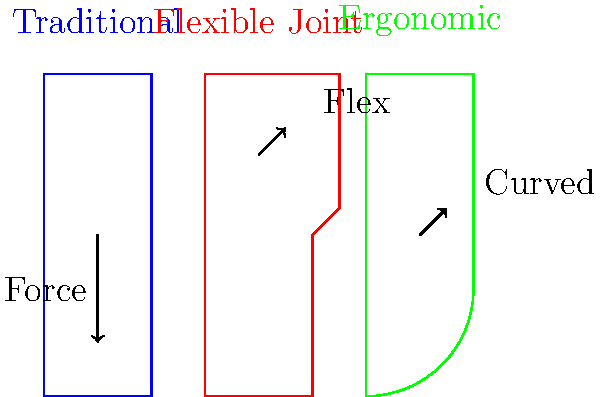Based on the cross-sectional views of different stirrup designs shown above, which design is likely to provide the highest mechanical efficiency for a jockey during a race, and why? To determine the most mechanically efficient stirrup design, we need to consider several factors:

1. Force distribution: The traditional stirrup (blue) has a flat base, which distributes force evenly but may not conform to the foot's shape.

2. Flexibility: The flexible joint stirrup (red) allows for some movement at the joint, potentially reducing strain on the rider's ankles and knees.

3. Ergonomics: The ergonomic stirrup (green) has a curved design that follows the natural shape of the foot.

4. Energy transfer: An efficient design should maximize the transfer of the rider's energy to the horse.

5. Stability: The design should provide a stable platform for the rider's foot.

Considering these factors:

- The traditional design is stable but lacks adaptability to foot movement.
- The flexible joint design allows for some ankle movement, potentially reducing fatigue.
- The ergonomic design conforms to the foot's shape, potentially providing better control and energy transfer.

For a jockey during a race, the ergonomic design is likely to provide the highest mechanical efficiency because:

1. It allows for better foot placement and control.
2. The curved shape may reduce the risk of the foot slipping through the stirrup.
3. It potentially provides better energy transfer from the rider to the horse due to increased contact area.
4. The ergonomic shape may reduce fatigue by supporting the foot's natural position.

As a retired jockey, you would likely appreciate the improved control and reduced fatigue offered by the ergonomic design, especially during long races where efficiency is crucial.
Answer: Ergonomic stirrup design, due to improved foot control, energy transfer, and reduced fatigue. 